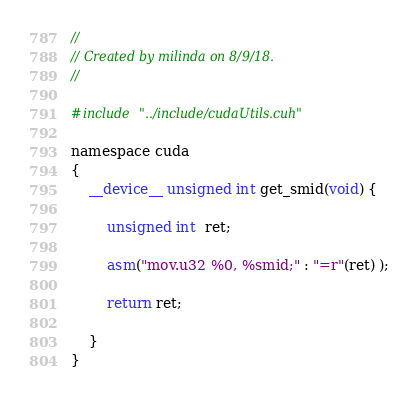Convert code to text. <code><loc_0><loc_0><loc_500><loc_500><_Cuda_>//
// Created by milinda on 8/9/18.
//

#include "../include/cudaUtils.cuh"

namespace cuda
{
    __device__ unsigned int get_smid(void) {

        unsigned int  ret;

        asm("mov.u32 %0, %smid;" : "=r"(ret) );

        return ret;

    }
}</code> 